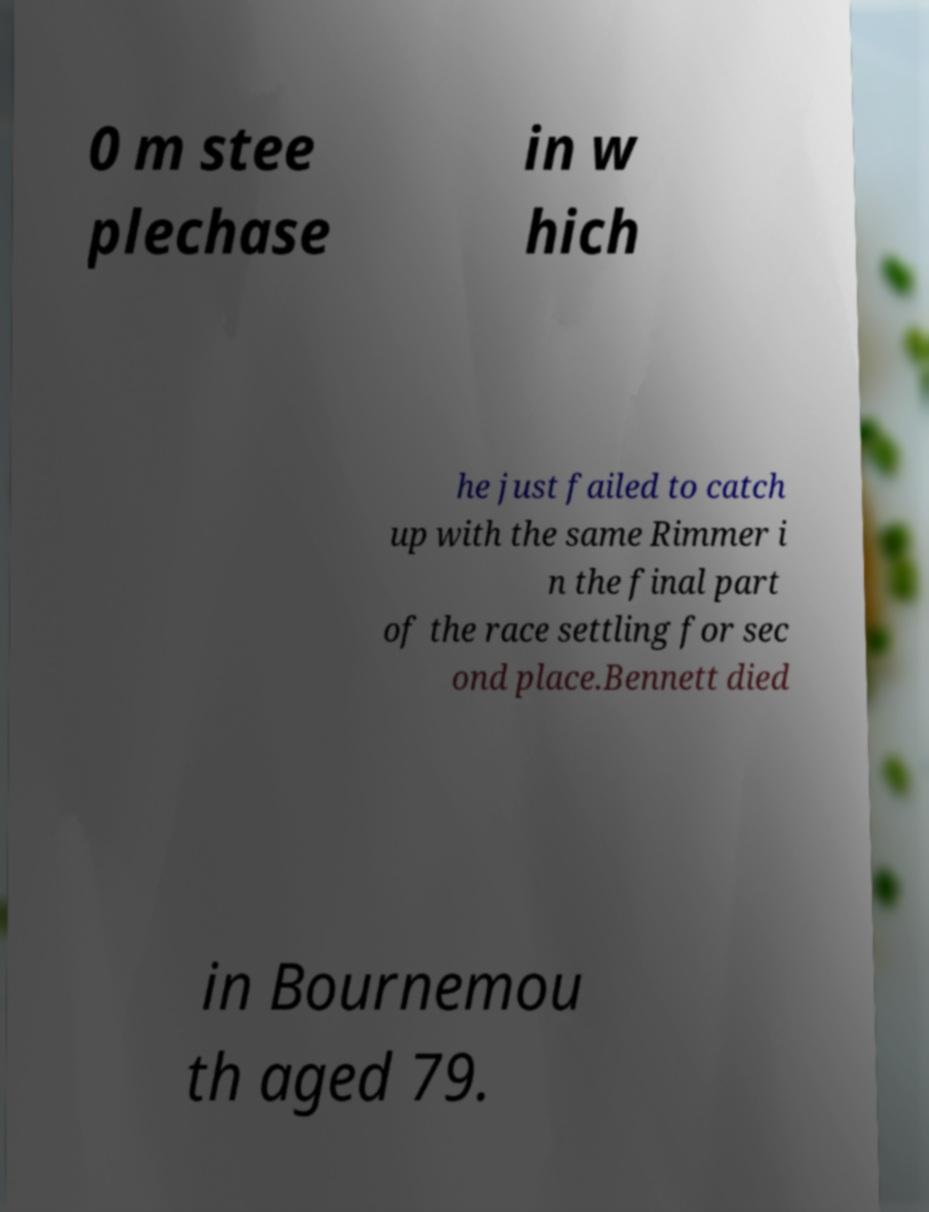There's text embedded in this image that I need extracted. Can you transcribe it verbatim? 0 m stee plechase in w hich he just failed to catch up with the same Rimmer i n the final part of the race settling for sec ond place.Bennett died in Bournemou th aged 79. 